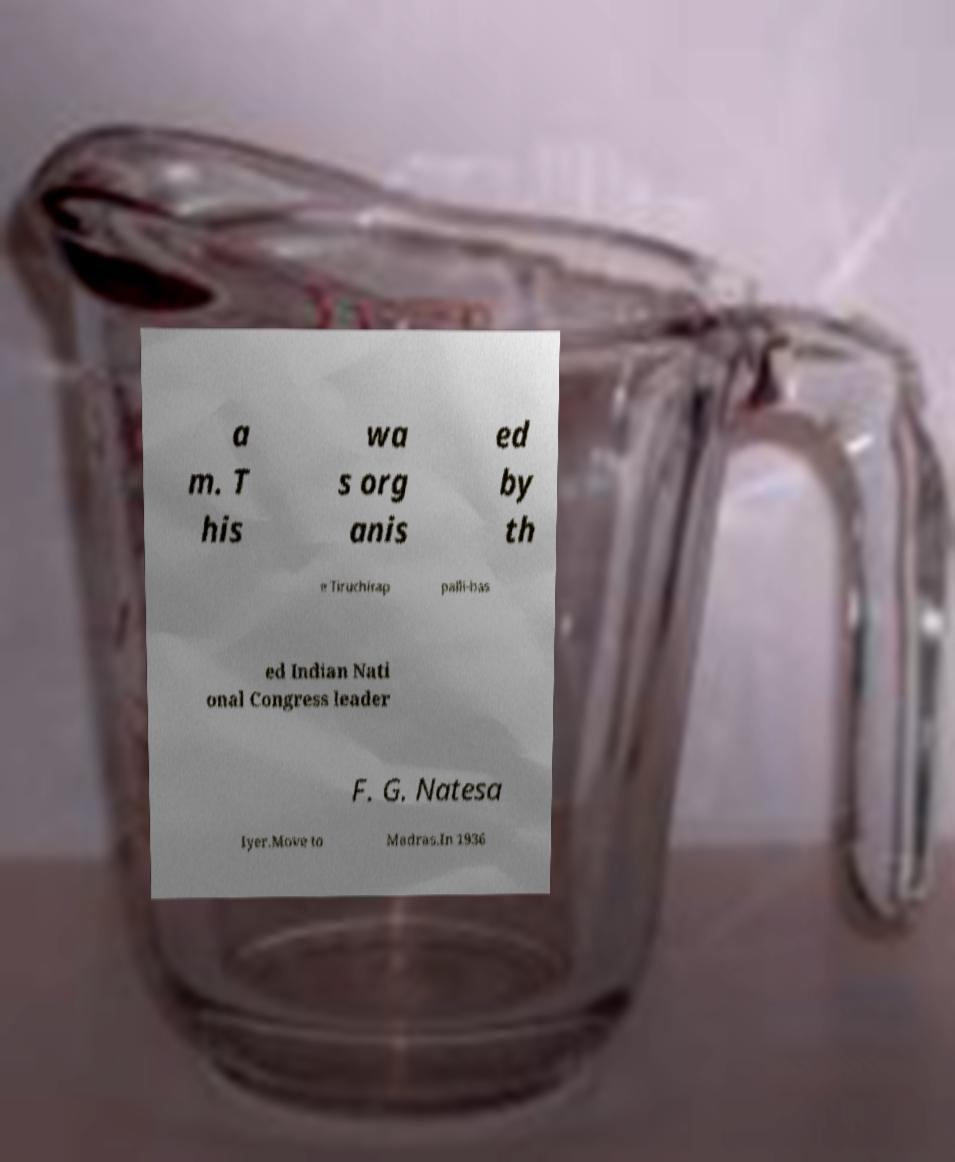What messages or text are displayed in this image? I need them in a readable, typed format. a m. T his wa s org anis ed by th e Tiruchirap palli-bas ed Indian Nati onal Congress leader F. G. Natesa Iyer.Move to Madras.In 1936 